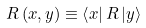Convert formula to latex. <formula><loc_0><loc_0><loc_500><loc_500>R \left ( x , y \right ) \equiv \left \langle x \right | R \left | y \right \rangle</formula> 